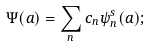<formula> <loc_0><loc_0><loc_500><loc_500>\Psi ( a ) = \sum _ { n } c _ { n } \psi _ { n } ^ { s } ( a ) ;</formula> 